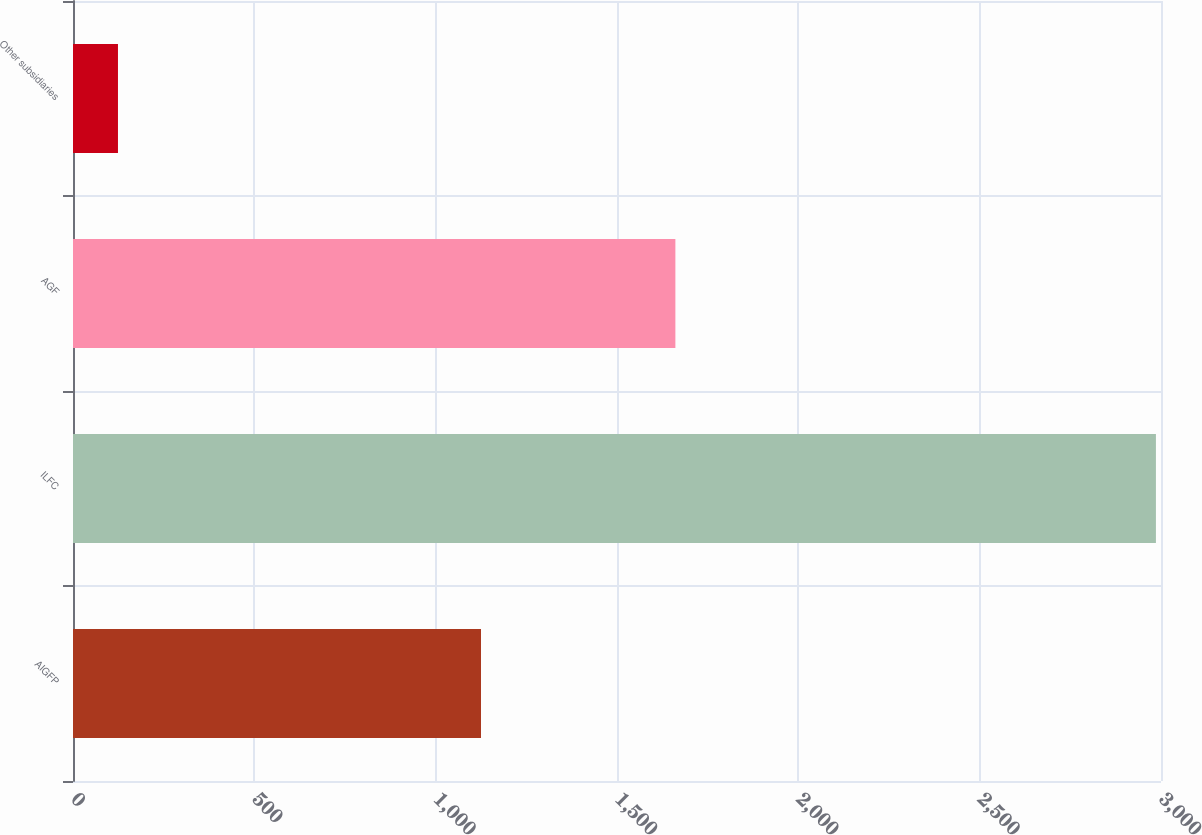Convert chart to OTSL. <chart><loc_0><loc_0><loc_500><loc_500><bar_chart><fcel>AIGFP<fcel>ILFC<fcel>AGF<fcel>Other subsidiaries<nl><fcel>1125<fcel>2986<fcel>1661<fcel>124<nl></chart> 